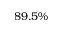Convert formula to latex. <formula><loc_0><loc_0><loc_500><loc_500>8 9 . 5 \%</formula> 